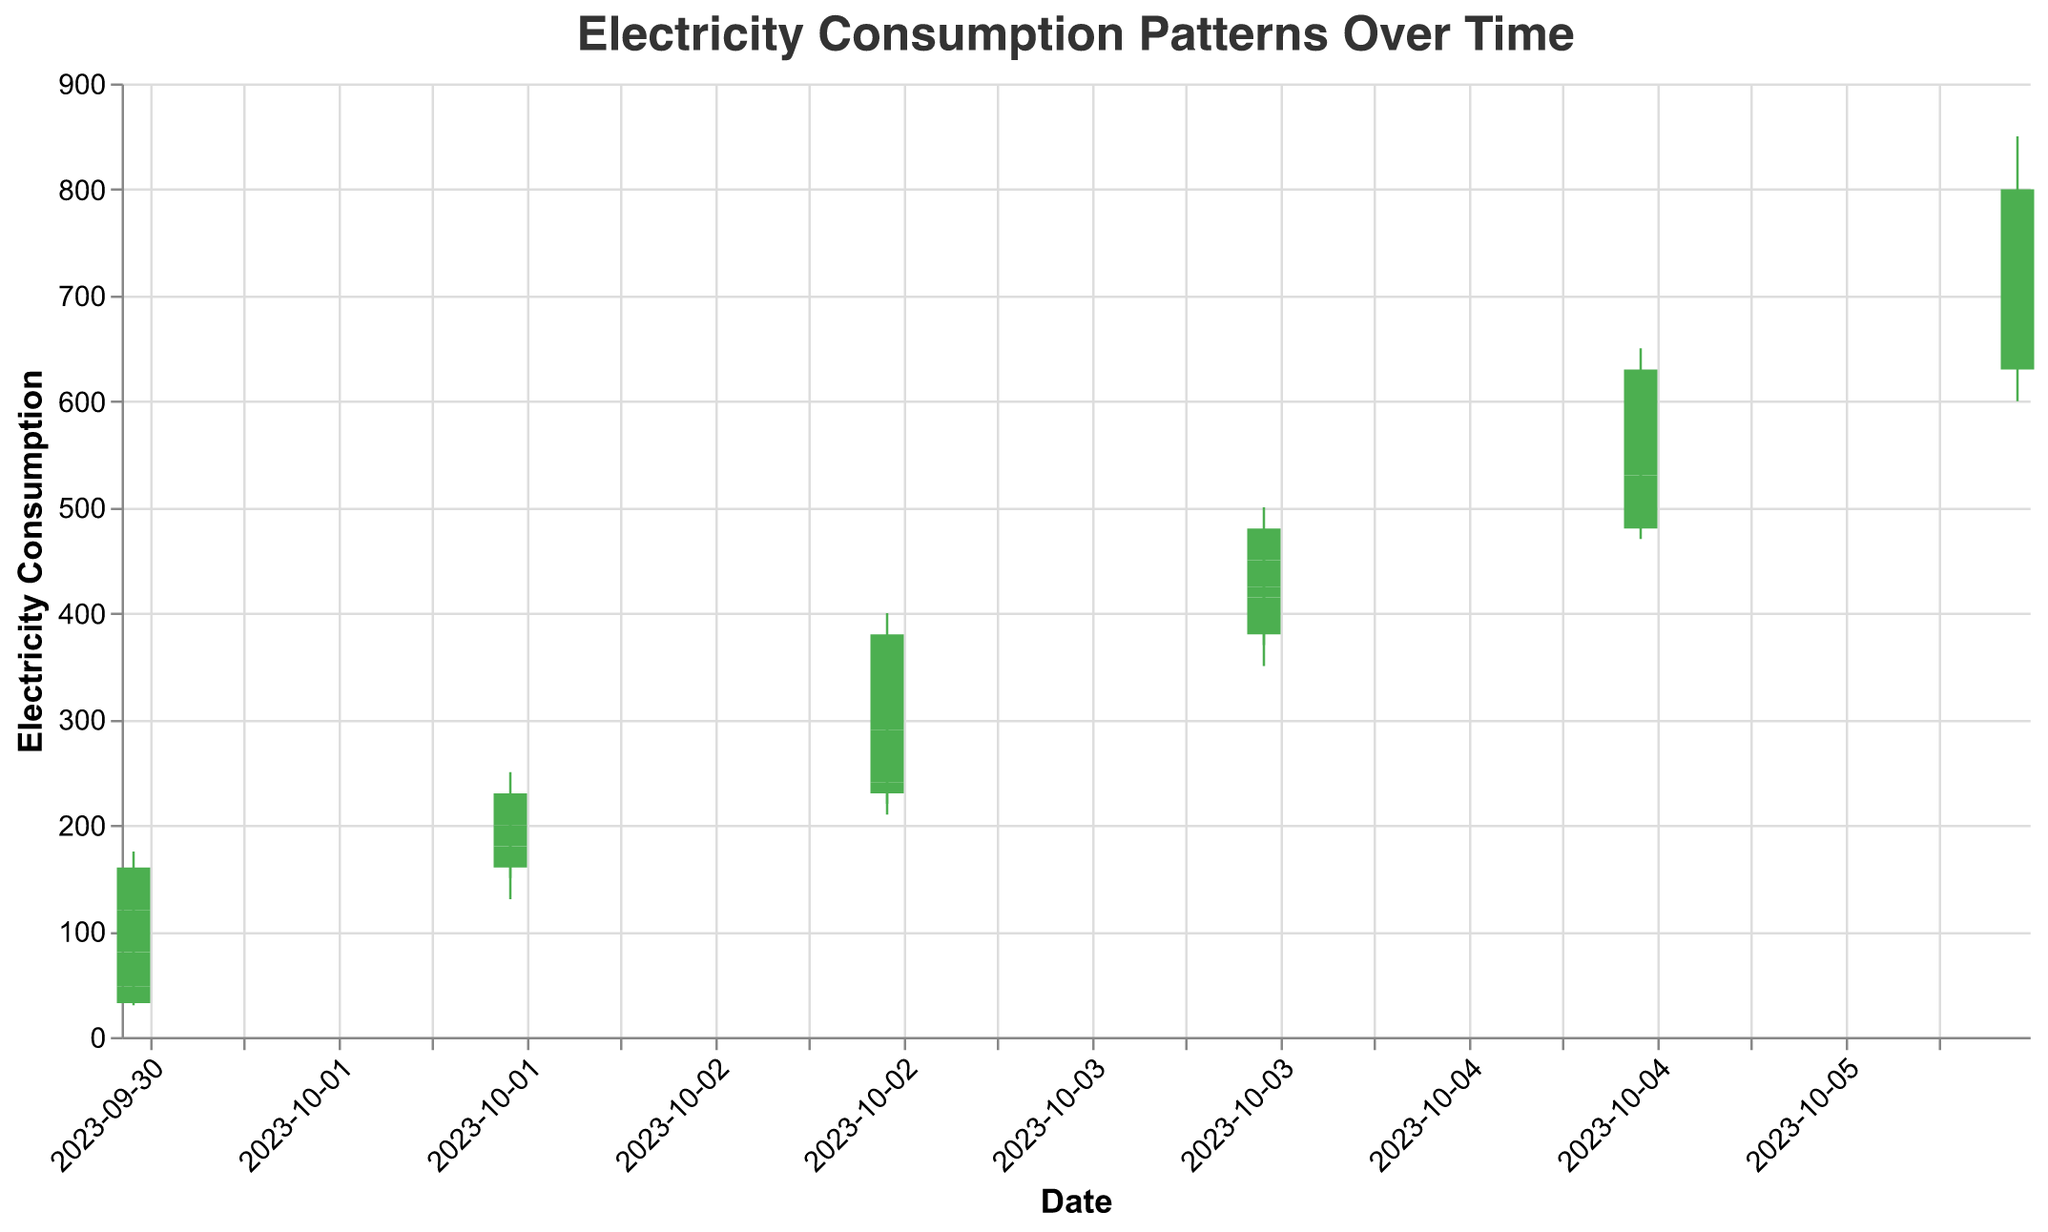What is the highest electricity consumption recorded in any time slot? Look at the y-axis representing electricity consumption and identify the highest point reached by any high value. The highest point in the plot is 850.
Answer: 850 What was the electricity consumption at the close of October 1st? Locate the date "2023-10-01" and find the "18:00-00:00" bar where the close value is 160.
Answer: 160 During which hour on October 2nd did the highest peak in electricity consumption occur? Look at the sticks for October 2nd and identify the one with the highest value, which is from "18:00-00:00" with a high of 250.
Answer: 18:00-00:00 By how much did electricity consumption increase from the open to the close on October 3rd for the time slot "12:00-18:00"? Find the "12:00-18:00" time slot of "2023-10-03" and calculate the difference between the close (320) and the open (290): 320 - 290 = 30.
Answer: 30 On which date and time slot did the electricity consumption show the most stability, as indicated by the smallest difference between high and low values? Calculate the difference between high and low for each bar and identify the smallest difference: on "2023-10-04" from "18:00-00:00", the difference is 75 (500 - 425).
Answer: 2023-10-04, 18:00-00:00 Between October 4th and October 5th (from 12:00-18:00), which day had higher electricity consumption at closing? Compare close values of October 4th (450) and October 5th (580) for the "12:00-18:00" time slot.
Answer: October 5th What was the electricity consumption range (high-low) for October 6th from 00:00-06:00? Identify the high and low values for the October 6th (00:00-06:00), 700 - 600 = 100.
Answer: 100 Which time slot shows the most significant decrease in electricity consumption from open to close? Compare the decrease (Open - Close) for all time slots and identify the greatest decrease: "06:00-12:00" on October 3rd has the largest decrease of 10 (240 - 290).
Answer: October 3rd, 06:00-12:00 Did electricity consumption generally trend upwards or downwards over the specified date range? Examine the general trend of closing prices from "2023-10-01" to "2023-10-06", shown by an overall uptrend.
Answer: Upwards 